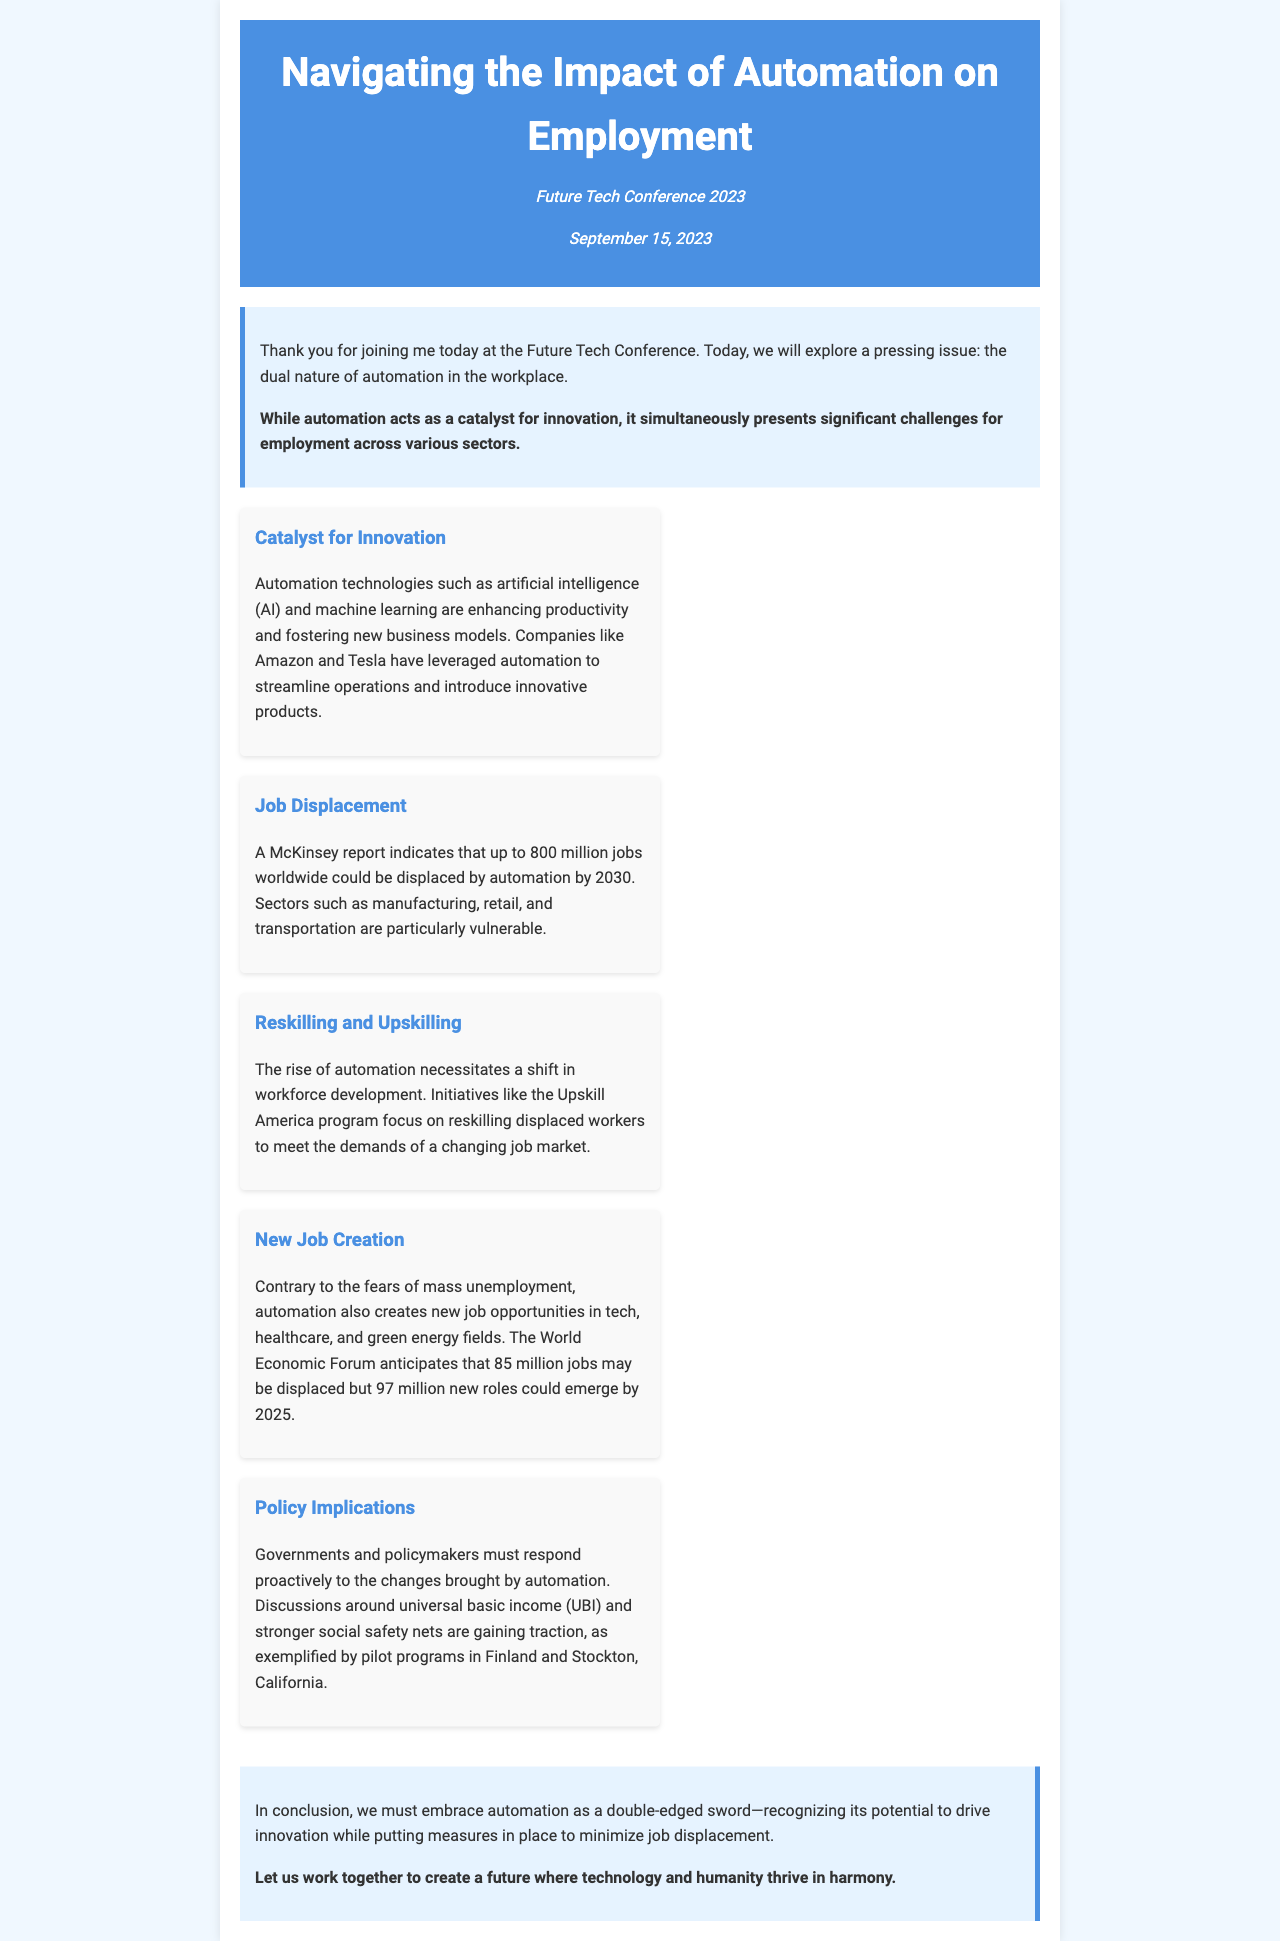What is the title of the keynote presentation? The title is found in the header of the document, which states "Navigating the Impact of Automation on Employment."
Answer: Navigating the Impact of Automation on Employment Who delivered the presentation? The document does not specify a name but indicates it was delivered at the Future Tech Conference in 2023.
Answer: Keynote speaker What is the date of the conference? The date mentioned in the event info section is September 15, 2023.
Answer: September 15, 2023 What major report does the document reference regarding job displacement? The document mentions a report by "McKinsey" concerning job displacement due to automation.
Answer: McKinsey How many jobs could be displaced by 2030 according to the McKinsey report? The document states that up to "800 million jobs" could be displaced worldwide by 2030.
Answer: 800 million jobs What program focuses on reskilling displaced workers? The Upskill America program is highlighted in the document as an initiative for reskilling workers.
Answer: Upskill America How many jobs could emerge due to automation by 2025? The World Economic Forum anticipates that "97 million new roles" could emerge by 2025.
Answer: 97 million What is a proposed response by governments to the impact of automation? The document discusses "universal basic income (UBI)" as a part of the policy implications.
Answer: Universal basic income (UBI) What dual nature of automation is discussed in the keynote? The keynote refers to automation as both a "catalyst for innovation" and a source of "job displacement."
Answer: Catalyst for innovation and job displacement 